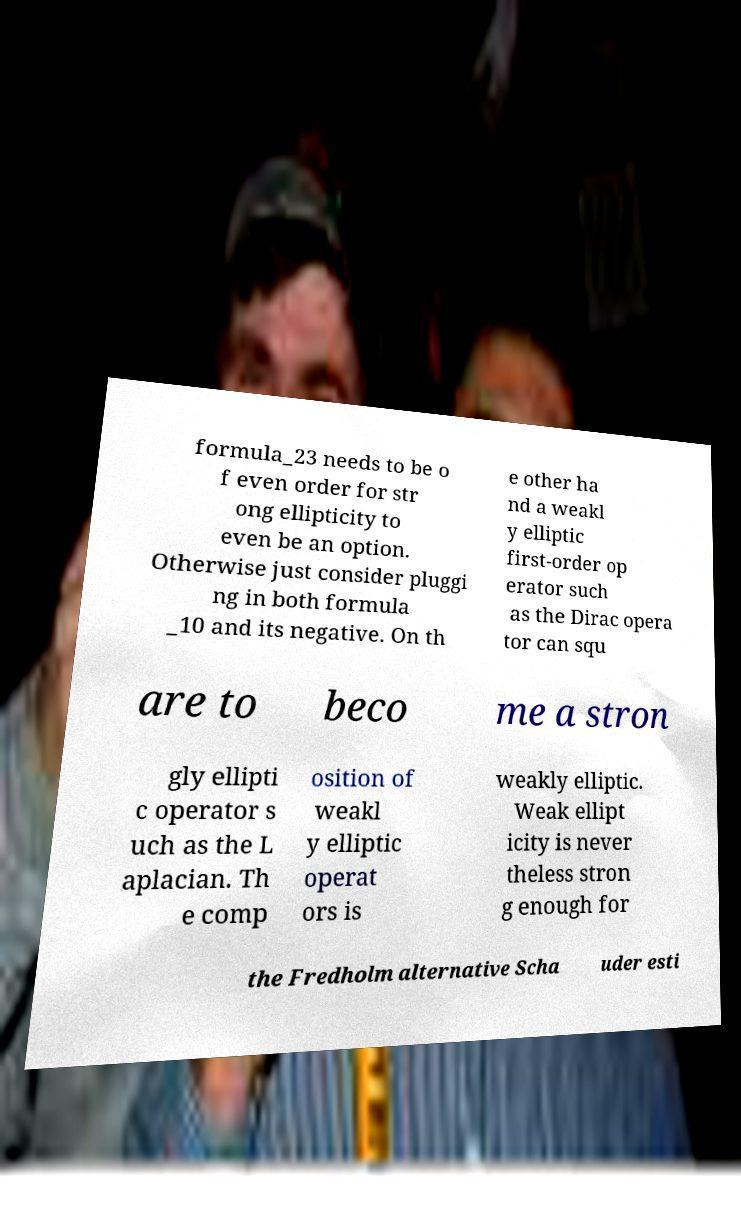Please read and relay the text visible in this image. What does it say? formula_23 needs to be o f even order for str ong ellipticity to even be an option. Otherwise just consider pluggi ng in both formula _10 and its negative. On th e other ha nd a weakl y elliptic first-order op erator such as the Dirac opera tor can squ are to beco me a stron gly ellipti c operator s uch as the L aplacian. Th e comp osition of weakl y elliptic operat ors is weakly elliptic. Weak ellipt icity is never theless stron g enough for the Fredholm alternative Scha uder esti 